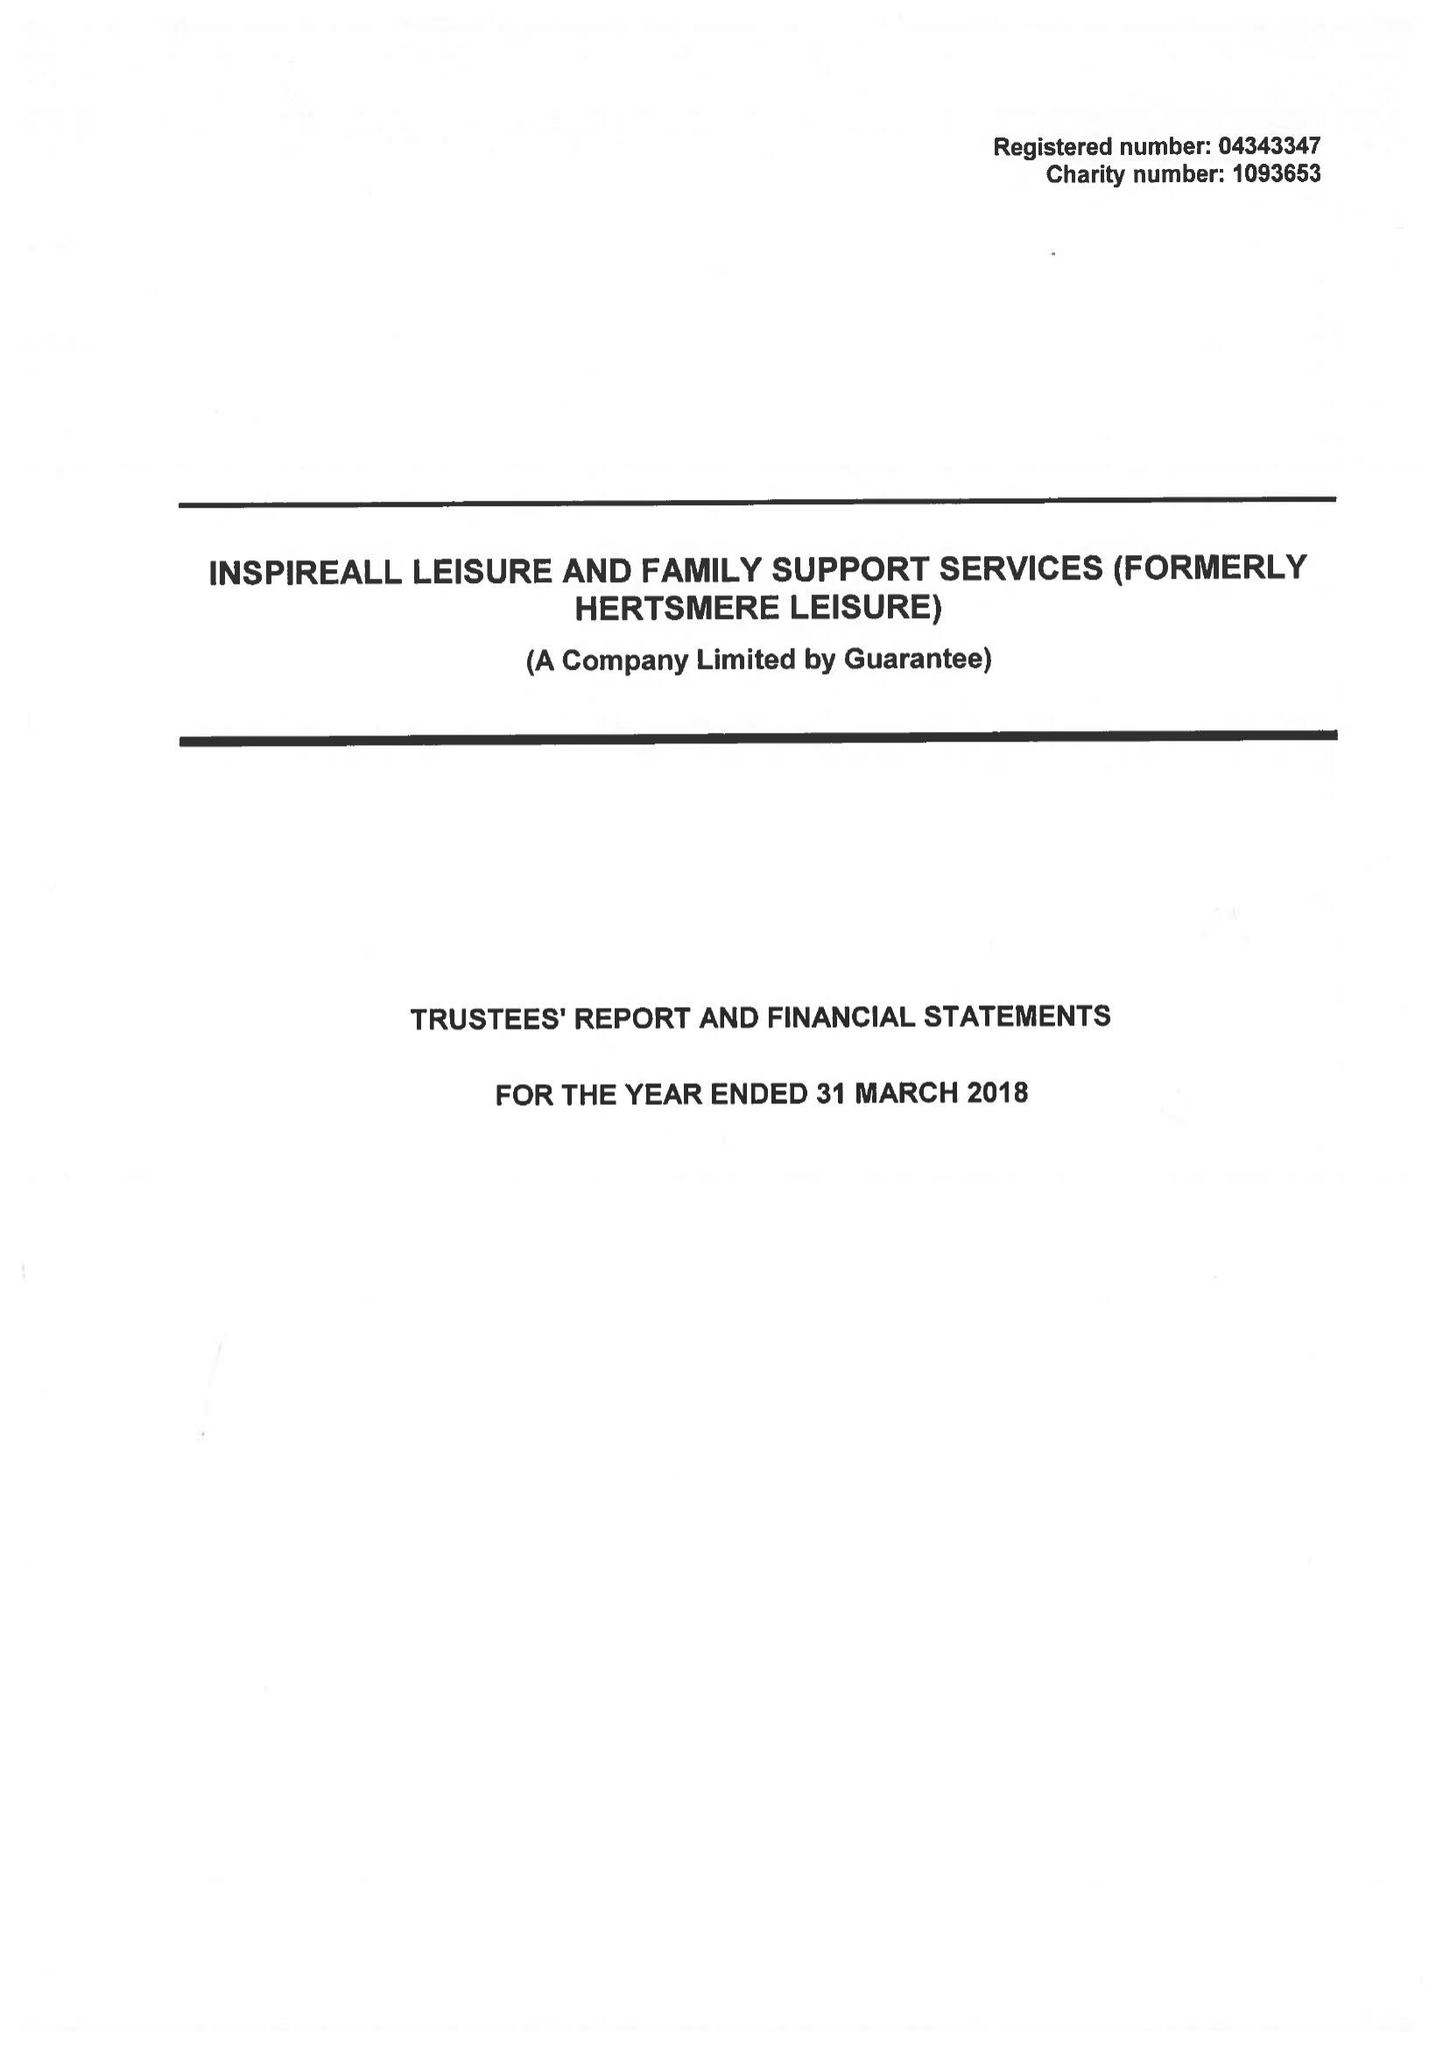What is the value for the address__street_line?
Answer the question using a single word or phrase. ELSTREE WAY 